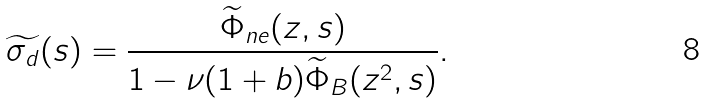Convert formula to latex. <formula><loc_0><loc_0><loc_500><loc_500>\widetilde { \sigma _ { d } } ( s ) = \frac { \widetilde { \Phi } _ { n e } ( z , s ) } { 1 - \nu ( 1 + b ) \widetilde { \Phi } _ { B } ( z ^ { 2 } , s ) } .</formula> 